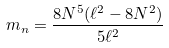Convert formula to latex. <formula><loc_0><loc_0><loc_500><loc_500>m _ { n } = \frac { 8 N ^ { 5 } ( \ell ^ { 2 } - 8 N ^ { 2 } ) } { 5 \ell ^ { 2 } }</formula> 